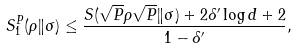<formula> <loc_0><loc_0><loc_500><loc_500>S ^ { P } _ { 1 } ( \rho \| \sigma ) \leq \frac { S ( \sqrt { P } \rho \sqrt { P } \| \sigma ) + 2 \delta ^ { \prime } \log d + 2 } { 1 - \delta ^ { \prime } } ,</formula> 